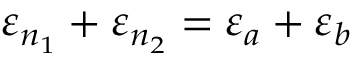<formula> <loc_0><loc_0><loc_500><loc_500>\varepsilon _ { n _ { 1 } } + \varepsilon _ { n _ { 2 } } = \varepsilon _ { a } + \varepsilon _ { b }</formula> 